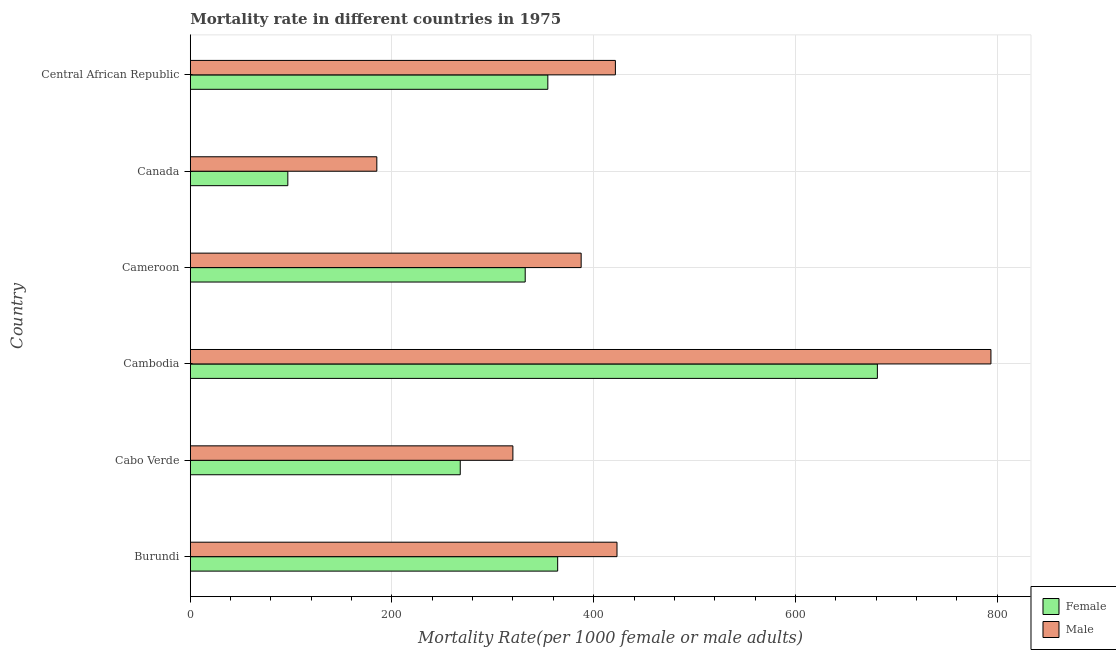What is the label of the 4th group of bars from the top?
Offer a terse response. Cambodia. In how many cases, is the number of bars for a given country not equal to the number of legend labels?
Keep it short and to the point. 0. What is the female mortality rate in Cabo Verde?
Your answer should be very brief. 267.7. Across all countries, what is the maximum male mortality rate?
Ensure brevity in your answer.  793.97. Across all countries, what is the minimum female mortality rate?
Provide a short and direct response. 96.71. In which country was the male mortality rate maximum?
Your answer should be very brief. Cambodia. In which country was the female mortality rate minimum?
Your response must be concise. Canada. What is the total male mortality rate in the graph?
Make the answer very short. 2531.17. What is the difference between the female mortality rate in Cabo Verde and that in Cameroon?
Your response must be concise. -64.42. What is the difference between the female mortality rate in Cameroon and the male mortality rate in Cambodia?
Your answer should be compact. -461.85. What is the average female mortality rate per country?
Make the answer very short. 349.46. What is the difference between the male mortality rate and female mortality rate in Central African Republic?
Your answer should be very brief. 67.01. In how many countries, is the male mortality rate greater than 400 ?
Provide a short and direct response. 3. What is the ratio of the male mortality rate in Burundi to that in Central African Republic?
Ensure brevity in your answer.  1. Is the male mortality rate in Cabo Verde less than that in Cambodia?
Give a very brief answer. Yes. What is the difference between the highest and the second highest female mortality rate?
Make the answer very short. 317.03. What is the difference between the highest and the lowest male mortality rate?
Your answer should be compact. 608.99. Is the sum of the male mortality rate in Cambodia and Canada greater than the maximum female mortality rate across all countries?
Keep it short and to the point. Yes. What does the 1st bar from the top in Cameroon represents?
Give a very brief answer. Male. What does the 2nd bar from the bottom in Central African Republic represents?
Give a very brief answer. Male. How many countries are there in the graph?
Your answer should be compact. 6. What is the difference between two consecutive major ticks on the X-axis?
Ensure brevity in your answer.  200. Are the values on the major ticks of X-axis written in scientific E-notation?
Keep it short and to the point. No. Where does the legend appear in the graph?
Your answer should be very brief. Bottom right. How are the legend labels stacked?
Keep it short and to the point. Vertical. What is the title of the graph?
Your answer should be very brief. Mortality rate in different countries in 1975. What is the label or title of the X-axis?
Offer a very short reply. Mortality Rate(per 1000 female or male adults). What is the Mortality Rate(per 1000 female or male adults) in Female in Burundi?
Make the answer very short. 364.32. What is the Mortality Rate(per 1000 female or male adults) in Male in Burundi?
Your answer should be compact. 423.15. What is the Mortality Rate(per 1000 female or male adults) in Female in Cabo Verde?
Provide a succinct answer. 267.7. What is the Mortality Rate(per 1000 female or male adults) in Male in Cabo Verde?
Ensure brevity in your answer.  319.91. What is the Mortality Rate(per 1000 female or male adults) of Female in Cambodia?
Your answer should be very brief. 681.35. What is the Mortality Rate(per 1000 female or male adults) in Male in Cambodia?
Give a very brief answer. 793.97. What is the Mortality Rate(per 1000 female or male adults) of Female in Cameroon?
Provide a succinct answer. 332.12. What is the Mortality Rate(per 1000 female or male adults) of Male in Cameroon?
Your answer should be compact. 387.6. What is the Mortality Rate(per 1000 female or male adults) of Female in Canada?
Offer a terse response. 96.71. What is the Mortality Rate(per 1000 female or male adults) in Male in Canada?
Give a very brief answer. 184.98. What is the Mortality Rate(per 1000 female or male adults) of Female in Central African Republic?
Your answer should be compact. 354.55. What is the Mortality Rate(per 1000 female or male adults) in Male in Central African Republic?
Your answer should be very brief. 421.56. Across all countries, what is the maximum Mortality Rate(per 1000 female or male adults) in Female?
Provide a succinct answer. 681.35. Across all countries, what is the maximum Mortality Rate(per 1000 female or male adults) of Male?
Keep it short and to the point. 793.97. Across all countries, what is the minimum Mortality Rate(per 1000 female or male adults) of Female?
Your answer should be compact. 96.71. Across all countries, what is the minimum Mortality Rate(per 1000 female or male adults) of Male?
Give a very brief answer. 184.98. What is the total Mortality Rate(per 1000 female or male adults) in Female in the graph?
Your response must be concise. 2096.76. What is the total Mortality Rate(per 1000 female or male adults) in Male in the graph?
Make the answer very short. 2531.17. What is the difference between the Mortality Rate(per 1000 female or male adults) in Female in Burundi and that in Cabo Verde?
Provide a short and direct response. 96.61. What is the difference between the Mortality Rate(per 1000 female or male adults) in Male in Burundi and that in Cabo Verde?
Ensure brevity in your answer.  103.24. What is the difference between the Mortality Rate(per 1000 female or male adults) in Female in Burundi and that in Cambodia?
Your answer should be very brief. -317.03. What is the difference between the Mortality Rate(per 1000 female or male adults) in Male in Burundi and that in Cambodia?
Provide a succinct answer. -370.82. What is the difference between the Mortality Rate(per 1000 female or male adults) in Female in Burundi and that in Cameroon?
Offer a terse response. 32.2. What is the difference between the Mortality Rate(per 1000 female or male adults) in Male in Burundi and that in Cameroon?
Your response must be concise. 35.55. What is the difference between the Mortality Rate(per 1000 female or male adults) in Female in Burundi and that in Canada?
Provide a short and direct response. 267.6. What is the difference between the Mortality Rate(per 1000 female or male adults) of Male in Burundi and that in Canada?
Keep it short and to the point. 238.17. What is the difference between the Mortality Rate(per 1000 female or male adults) of Female in Burundi and that in Central African Republic?
Provide a succinct answer. 9.77. What is the difference between the Mortality Rate(per 1000 female or male adults) in Male in Burundi and that in Central African Republic?
Your answer should be very brief. 1.59. What is the difference between the Mortality Rate(per 1000 female or male adults) of Female in Cabo Verde and that in Cambodia?
Your answer should be very brief. -413.65. What is the difference between the Mortality Rate(per 1000 female or male adults) in Male in Cabo Verde and that in Cambodia?
Offer a terse response. -474.06. What is the difference between the Mortality Rate(per 1000 female or male adults) of Female in Cabo Verde and that in Cameroon?
Offer a very short reply. -64.42. What is the difference between the Mortality Rate(per 1000 female or male adults) of Male in Cabo Verde and that in Cameroon?
Keep it short and to the point. -67.69. What is the difference between the Mortality Rate(per 1000 female or male adults) in Female in Cabo Verde and that in Canada?
Provide a succinct answer. 170.99. What is the difference between the Mortality Rate(per 1000 female or male adults) of Male in Cabo Verde and that in Canada?
Provide a succinct answer. 134.93. What is the difference between the Mortality Rate(per 1000 female or male adults) of Female in Cabo Verde and that in Central African Republic?
Your response must be concise. -86.85. What is the difference between the Mortality Rate(per 1000 female or male adults) in Male in Cabo Verde and that in Central African Republic?
Your answer should be very brief. -101.65. What is the difference between the Mortality Rate(per 1000 female or male adults) of Female in Cambodia and that in Cameroon?
Your answer should be very brief. 349.23. What is the difference between the Mortality Rate(per 1000 female or male adults) in Male in Cambodia and that in Cameroon?
Keep it short and to the point. 406.37. What is the difference between the Mortality Rate(per 1000 female or male adults) of Female in Cambodia and that in Canada?
Keep it short and to the point. 584.64. What is the difference between the Mortality Rate(per 1000 female or male adults) of Male in Cambodia and that in Canada?
Your answer should be compact. 608.99. What is the difference between the Mortality Rate(per 1000 female or male adults) in Female in Cambodia and that in Central African Republic?
Give a very brief answer. 326.8. What is the difference between the Mortality Rate(per 1000 female or male adults) in Male in Cambodia and that in Central African Republic?
Your answer should be compact. 372.42. What is the difference between the Mortality Rate(per 1000 female or male adults) of Female in Cameroon and that in Canada?
Give a very brief answer. 235.41. What is the difference between the Mortality Rate(per 1000 female or male adults) of Male in Cameroon and that in Canada?
Keep it short and to the point. 202.62. What is the difference between the Mortality Rate(per 1000 female or male adults) of Female in Cameroon and that in Central African Republic?
Provide a short and direct response. -22.43. What is the difference between the Mortality Rate(per 1000 female or male adults) of Male in Cameroon and that in Central African Republic?
Offer a very short reply. -33.96. What is the difference between the Mortality Rate(per 1000 female or male adults) of Female in Canada and that in Central African Republic?
Your response must be concise. -257.84. What is the difference between the Mortality Rate(per 1000 female or male adults) of Male in Canada and that in Central African Republic?
Provide a succinct answer. -236.58. What is the difference between the Mortality Rate(per 1000 female or male adults) of Female in Burundi and the Mortality Rate(per 1000 female or male adults) of Male in Cabo Verde?
Offer a terse response. 44.41. What is the difference between the Mortality Rate(per 1000 female or male adults) in Female in Burundi and the Mortality Rate(per 1000 female or male adults) in Male in Cambodia?
Offer a very short reply. -429.66. What is the difference between the Mortality Rate(per 1000 female or male adults) of Female in Burundi and the Mortality Rate(per 1000 female or male adults) of Male in Cameroon?
Provide a short and direct response. -23.28. What is the difference between the Mortality Rate(per 1000 female or male adults) of Female in Burundi and the Mortality Rate(per 1000 female or male adults) of Male in Canada?
Make the answer very short. 179.34. What is the difference between the Mortality Rate(per 1000 female or male adults) of Female in Burundi and the Mortality Rate(per 1000 female or male adults) of Male in Central African Republic?
Provide a short and direct response. -57.24. What is the difference between the Mortality Rate(per 1000 female or male adults) in Female in Cabo Verde and the Mortality Rate(per 1000 female or male adults) in Male in Cambodia?
Ensure brevity in your answer.  -526.27. What is the difference between the Mortality Rate(per 1000 female or male adults) of Female in Cabo Verde and the Mortality Rate(per 1000 female or male adults) of Male in Cameroon?
Offer a terse response. -119.89. What is the difference between the Mortality Rate(per 1000 female or male adults) in Female in Cabo Verde and the Mortality Rate(per 1000 female or male adults) in Male in Canada?
Ensure brevity in your answer.  82.72. What is the difference between the Mortality Rate(per 1000 female or male adults) in Female in Cabo Verde and the Mortality Rate(per 1000 female or male adults) in Male in Central African Republic?
Your response must be concise. -153.85. What is the difference between the Mortality Rate(per 1000 female or male adults) of Female in Cambodia and the Mortality Rate(per 1000 female or male adults) of Male in Cameroon?
Give a very brief answer. 293.75. What is the difference between the Mortality Rate(per 1000 female or male adults) in Female in Cambodia and the Mortality Rate(per 1000 female or male adults) in Male in Canada?
Provide a short and direct response. 496.37. What is the difference between the Mortality Rate(per 1000 female or male adults) of Female in Cambodia and the Mortality Rate(per 1000 female or male adults) of Male in Central African Republic?
Give a very brief answer. 259.79. What is the difference between the Mortality Rate(per 1000 female or male adults) of Female in Cameroon and the Mortality Rate(per 1000 female or male adults) of Male in Canada?
Provide a short and direct response. 147.14. What is the difference between the Mortality Rate(per 1000 female or male adults) in Female in Cameroon and the Mortality Rate(per 1000 female or male adults) in Male in Central African Republic?
Offer a terse response. -89.44. What is the difference between the Mortality Rate(per 1000 female or male adults) of Female in Canada and the Mortality Rate(per 1000 female or male adults) of Male in Central African Republic?
Offer a terse response. -324.85. What is the average Mortality Rate(per 1000 female or male adults) of Female per country?
Your answer should be compact. 349.46. What is the average Mortality Rate(per 1000 female or male adults) of Male per country?
Your answer should be very brief. 421.86. What is the difference between the Mortality Rate(per 1000 female or male adults) in Female and Mortality Rate(per 1000 female or male adults) in Male in Burundi?
Offer a terse response. -58.83. What is the difference between the Mortality Rate(per 1000 female or male adults) in Female and Mortality Rate(per 1000 female or male adults) in Male in Cabo Verde?
Offer a very short reply. -52.2. What is the difference between the Mortality Rate(per 1000 female or male adults) in Female and Mortality Rate(per 1000 female or male adults) in Male in Cambodia?
Make the answer very short. -112.62. What is the difference between the Mortality Rate(per 1000 female or male adults) of Female and Mortality Rate(per 1000 female or male adults) of Male in Cameroon?
Your response must be concise. -55.48. What is the difference between the Mortality Rate(per 1000 female or male adults) in Female and Mortality Rate(per 1000 female or male adults) in Male in Canada?
Keep it short and to the point. -88.27. What is the difference between the Mortality Rate(per 1000 female or male adults) in Female and Mortality Rate(per 1000 female or male adults) in Male in Central African Republic?
Keep it short and to the point. -67.01. What is the ratio of the Mortality Rate(per 1000 female or male adults) in Female in Burundi to that in Cabo Verde?
Ensure brevity in your answer.  1.36. What is the ratio of the Mortality Rate(per 1000 female or male adults) of Male in Burundi to that in Cabo Verde?
Make the answer very short. 1.32. What is the ratio of the Mortality Rate(per 1000 female or male adults) of Female in Burundi to that in Cambodia?
Provide a succinct answer. 0.53. What is the ratio of the Mortality Rate(per 1000 female or male adults) of Male in Burundi to that in Cambodia?
Keep it short and to the point. 0.53. What is the ratio of the Mortality Rate(per 1000 female or male adults) of Female in Burundi to that in Cameroon?
Your response must be concise. 1.1. What is the ratio of the Mortality Rate(per 1000 female or male adults) of Male in Burundi to that in Cameroon?
Ensure brevity in your answer.  1.09. What is the ratio of the Mortality Rate(per 1000 female or male adults) of Female in Burundi to that in Canada?
Offer a very short reply. 3.77. What is the ratio of the Mortality Rate(per 1000 female or male adults) of Male in Burundi to that in Canada?
Offer a terse response. 2.29. What is the ratio of the Mortality Rate(per 1000 female or male adults) of Female in Burundi to that in Central African Republic?
Keep it short and to the point. 1.03. What is the ratio of the Mortality Rate(per 1000 female or male adults) of Male in Burundi to that in Central African Republic?
Your answer should be very brief. 1. What is the ratio of the Mortality Rate(per 1000 female or male adults) of Female in Cabo Verde to that in Cambodia?
Provide a succinct answer. 0.39. What is the ratio of the Mortality Rate(per 1000 female or male adults) of Male in Cabo Verde to that in Cambodia?
Provide a succinct answer. 0.4. What is the ratio of the Mortality Rate(per 1000 female or male adults) in Female in Cabo Verde to that in Cameroon?
Your response must be concise. 0.81. What is the ratio of the Mortality Rate(per 1000 female or male adults) of Male in Cabo Verde to that in Cameroon?
Keep it short and to the point. 0.83. What is the ratio of the Mortality Rate(per 1000 female or male adults) of Female in Cabo Verde to that in Canada?
Your answer should be compact. 2.77. What is the ratio of the Mortality Rate(per 1000 female or male adults) in Male in Cabo Verde to that in Canada?
Your response must be concise. 1.73. What is the ratio of the Mortality Rate(per 1000 female or male adults) of Female in Cabo Verde to that in Central African Republic?
Your response must be concise. 0.76. What is the ratio of the Mortality Rate(per 1000 female or male adults) of Male in Cabo Verde to that in Central African Republic?
Offer a very short reply. 0.76. What is the ratio of the Mortality Rate(per 1000 female or male adults) in Female in Cambodia to that in Cameroon?
Your answer should be very brief. 2.05. What is the ratio of the Mortality Rate(per 1000 female or male adults) in Male in Cambodia to that in Cameroon?
Your response must be concise. 2.05. What is the ratio of the Mortality Rate(per 1000 female or male adults) in Female in Cambodia to that in Canada?
Offer a very short reply. 7.05. What is the ratio of the Mortality Rate(per 1000 female or male adults) of Male in Cambodia to that in Canada?
Give a very brief answer. 4.29. What is the ratio of the Mortality Rate(per 1000 female or male adults) in Female in Cambodia to that in Central African Republic?
Your answer should be compact. 1.92. What is the ratio of the Mortality Rate(per 1000 female or male adults) in Male in Cambodia to that in Central African Republic?
Offer a terse response. 1.88. What is the ratio of the Mortality Rate(per 1000 female or male adults) in Female in Cameroon to that in Canada?
Ensure brevity in your answer.  3.43. What is the ratio of the Mortality Rate(per 1000 female or male adults) of Male in Cameroon to that in Canada?
Provide a short and direct response. 2.1. What is the ratio of the Mortality Rate(per 1000 female or male adults) in Female in Cameroon to that in Central African Republic?
Your answer should be very brief. 0.94. What is the ratio of the Mortality Rate(per 1000 female or male adults) of Male in Cameroon to that in Central African Republic?
Provide a short and direct response. 0.92. What is the ratio of the Mortality Rate(per 1000 female or male adults) of Female in Canada to that in Central African Republic?
Your response must be concise. 0.27. What is the ratio of the Mortality Rate(per 1000 female or male adults) of Male in Canada to that in Central African Republic?
Ensure brevity in your answer.  0.44. What is the difference between the highest and the second highest Mortality Rate(per 1000 female or male adults) of Female?
Provide a succinct answer. 317.03. What is the difference between the highest and the second highest Mortality Rate(per 1000 female or male adults) in Male?
Offer a very short reply. 370.82. What is the difference between the highest and the lowest Mortality Rate(per 1000 female or male adults) in Female?
Offer a terse response. 584.64. What is the difference between the highest and the lowest Mortality Rate(per 1000 female or male adults) in Male?
Offer a very short reply. 608.99. 